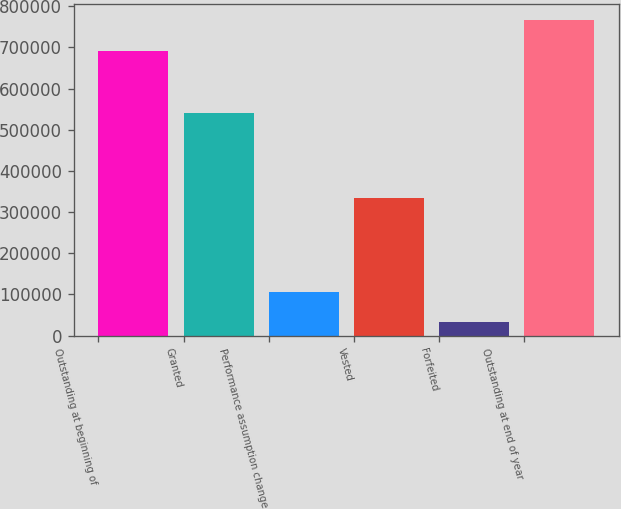<chart> <loc_0><loc_0><loc_500><loc_500><bar_chart><fcel>Outstanding at beginning of<fcel>Granted<fcel>Performance assumption change<fcel>Vested<fcel>Forfeited<fcel>Outstanding at end of year<nl><fcel>691032<fcel>541623<fcel>106421<fcel>333980<fcel>33111<fcel>766209<nl></chart> 